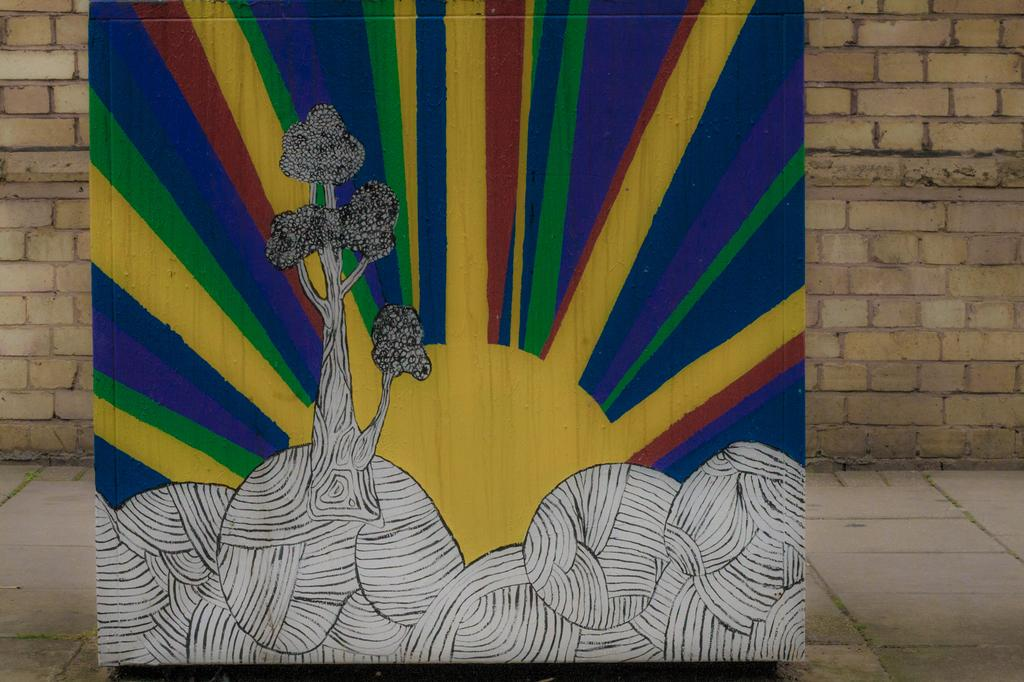What can be seen in the image? There is an object in the image. What is special about the object? The object has a painting on it. What is visible behind the object? There is a wall behind the object. Can you see a fork being used by a bear under an umbrella in the image? No, there is no fork, bear, or umbrella present in the image. 